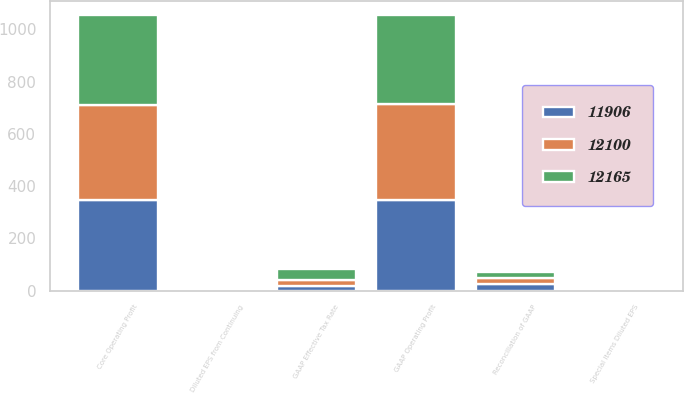Convert chart. <chart><loc_0><loc_0><loc_500><loc_500><stacked_bar_chart><ecel><fcel>Reconciliation of GAAP<fcel>GAAP Operating Profit<fcel>Core Operating Profit<fcel>Diluted EPS from Continuing<fcel>Special Items Diluted EPS<fcel>GAAP Effective Tax Rate<nl><fcel>11906<fcel>24.3<fcel>348<fcel>347<fcel>3.17<fcel>1.52<fcel>16.2<nl><fcel>12165<fcel>24.3<fcel>341<fcel>345<fcel>2.96<fcel>0.81<fcel>41.1<nl><fcel>12100<fcel>24.3<fcel>367<fcel>362<fcel>2.46<fcel>0.08<fcel>24.3<nl></chart> 